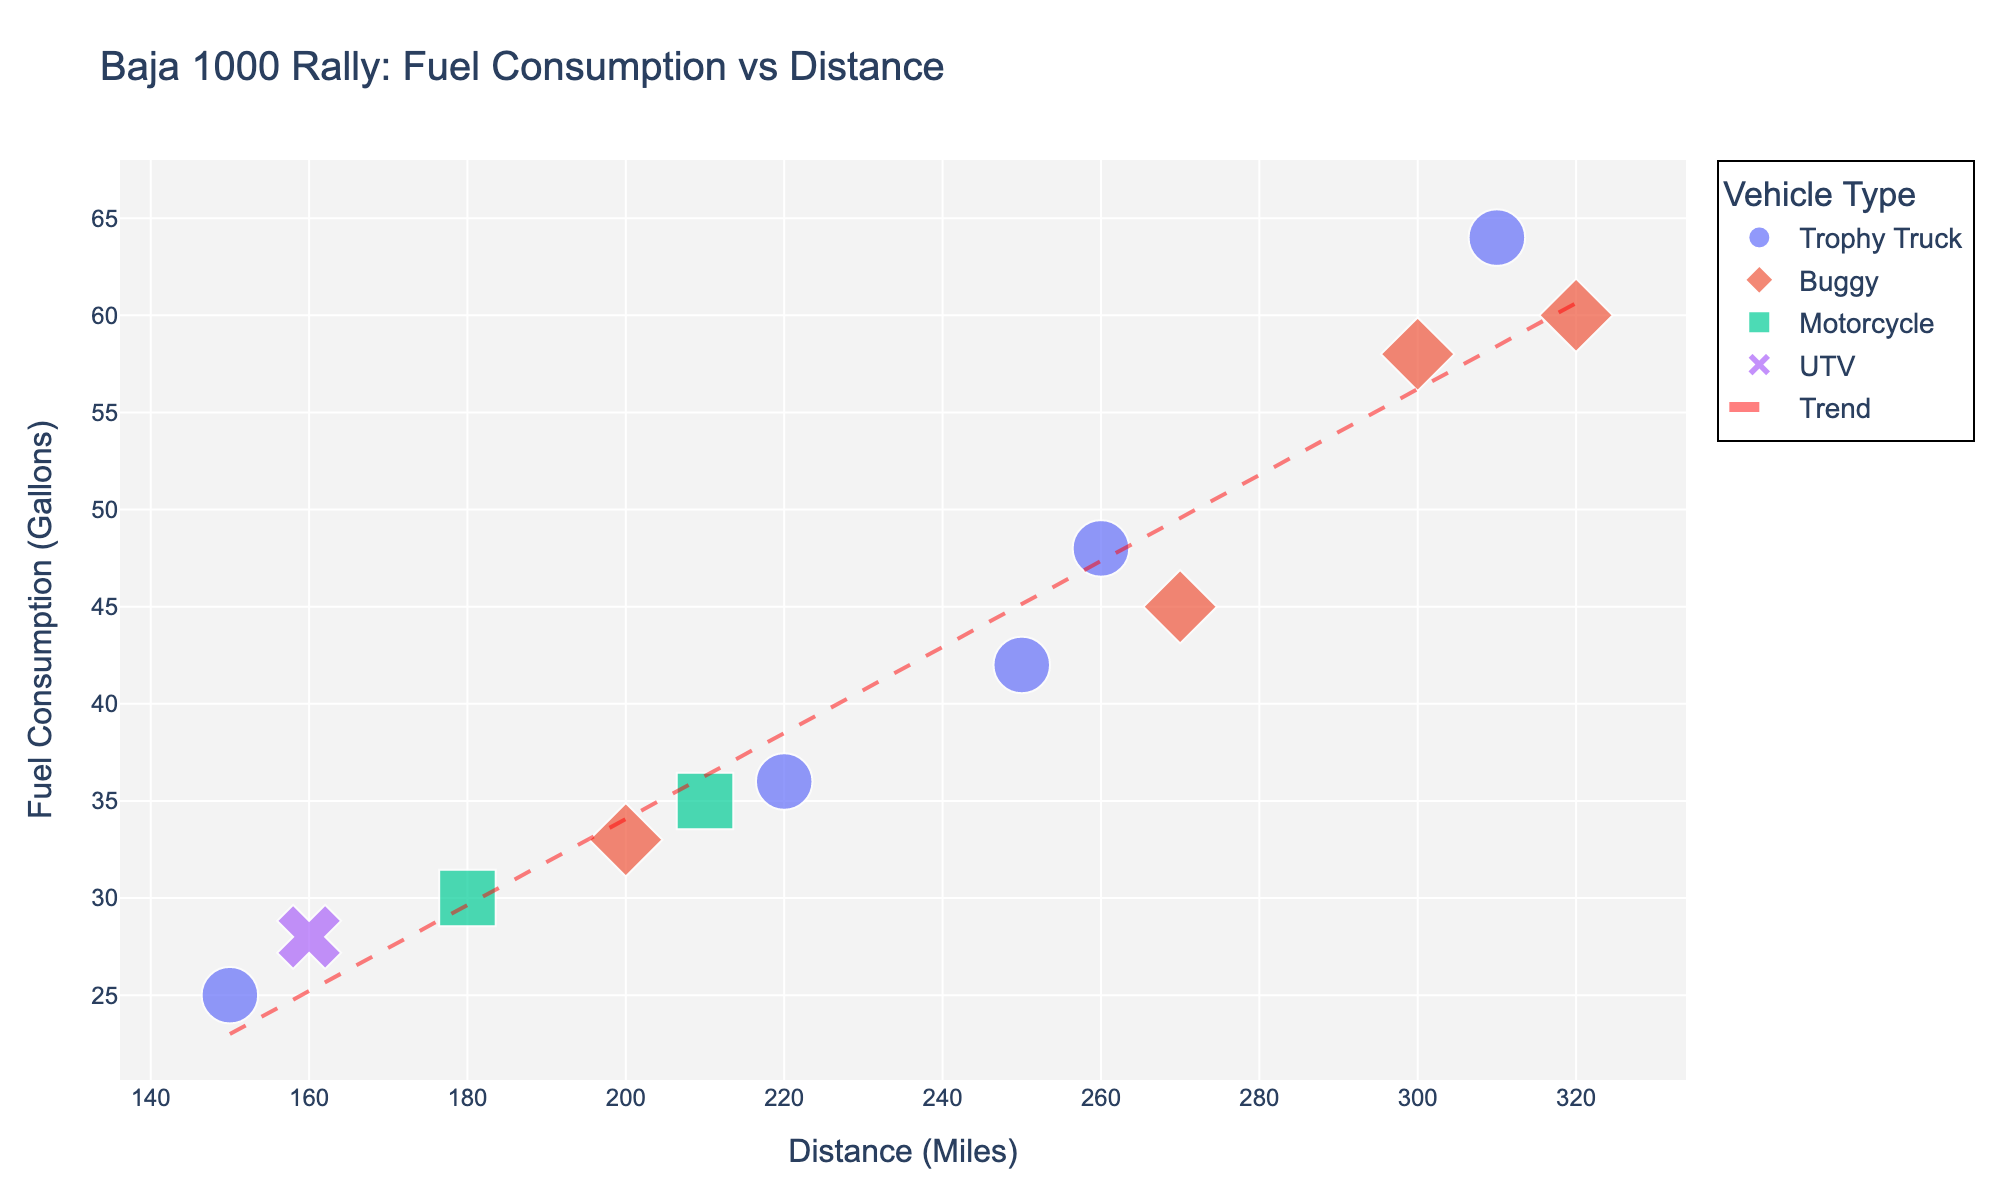What's the title of the scatter plot? The title is at the top of the figure, and it provides a summary of what the plot is about. Look at the text at the top of the plot to find the title.
Answer: Baja 1000 Rally: Fuel Consumption vs Distance How many different vehicle types are represented in the plot? Different vehicle types are indicated by different colors and symbols. Observe the legend on the right side of the plot to count the distinct categories.
Answer: 4 What is the trend line's color and style? Look for the line that is used to indicate the trend across the scatter plots. It is typically a different style and color compared to the scatter points.
Answer: Red, dashed Which vehicle type has the highest fuel consumption for a given distance? By examining the scatter points, find the point that lies highest on the y-axis and note the vehicle type represented by the symbol and color.
Answer: Trophy Truck What is the approximate slope of the trend line? The slope of the trend line represents the rate of change in fuel consumption per mile. By comparing the rise over the run between two points on the trend line, one can estimate the slope.
Answer: Approximately 0.2 (fuel consumption increases by 0.2 gallons per mile) What's the average fuel consumption for distances of 250 miles and above? Identify the points with distances 250 miles and above, sum their fuel consumption values, and divide by the number of such points.
Answer: (42 + 58 + 45 + 64 + 48 + 60) / 6 = 52.83 Which year had the highest fuel consumption, and for which vehicle? Identify the points with the highest y-axis value and check the hover information or legend to note the year and vehicle type.
Answer: 2021, Trophy Truck Are Buggies more fuel-efficient than Trophy Trucks for similar distances? Compare the scatter points for Buggies and Trophy Trucks at similar x-axis (distance) values to compare their respective y-axis (fuel consumption) values.
Answer: Yes, generally What’s the fuel consumption difference for distances of 160 miles between UTV and Motorcycle? Locate the data points for UTV and Motorcycle at 160 miles on the x-axis and subtract their y-axis fuel consumption values.
Answer: 2 gallons (UTV: 28, Motorcycle: 30) Is the trend line a good fit for the data points? Evaluate how closely the scatter points align with the trend line. If most points are near the trend line, it can be considered a good fit.
Answer: Yes 